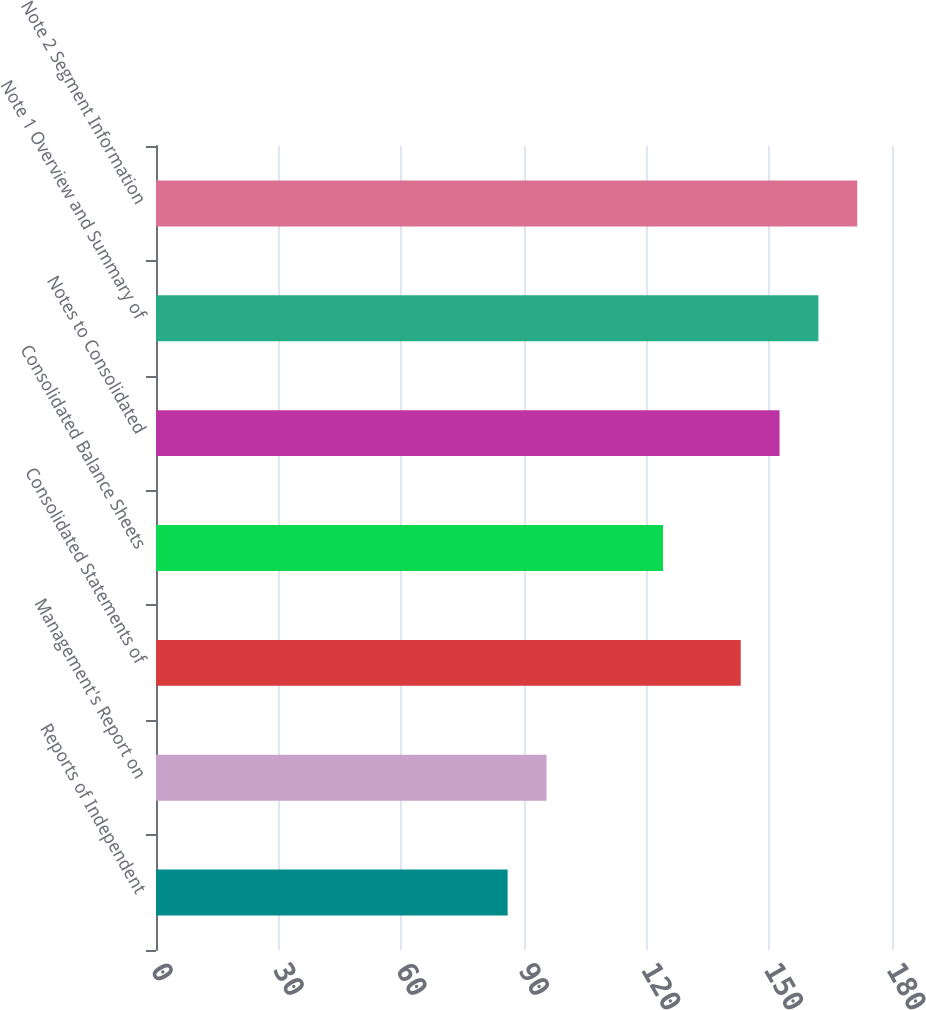Convert chart to OTSL. <chart><loc_0><loc_0><loc_500><loc_500><bar_chart><fcel>Reports of Independent<fcel>Management's Report on<fcel>Consolidated Statements of<fcel>Consolidated Balance Sheets<fcel>Notes to Consolidated<fcel>Note 1 Overview and Summary of<fcel>Note 2 Segment Information<nl><fcel>86<fcel>95.5<fcel>143<fcel>124<fcel>152.5<fcel>162<fcel>171.5<nl></chart> 